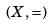Convert formula to latex. <formula><loc_0><loc_0><loc_500><loc_500>( X , = )</formula> 